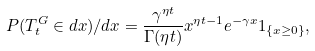<formula> <loc_0><loc_0><loc_500><loc_500>P ( T ^ { G } _ { t } \in d x ) / d x = \frac { \gamma ^ { \eta t } } { \Gamma ( \eta t ) } x ^ { \eta t - 1 } e ^ { - \gamma x } 1 _ { \{ x \geq 0 \} } ,</formula> 